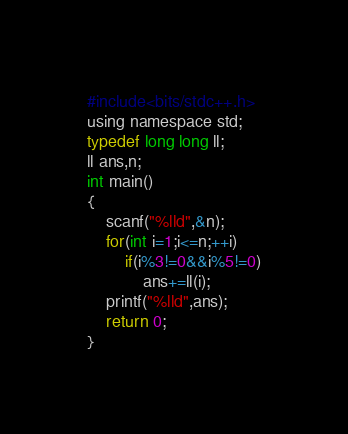Convert code to text. <code><loc_0><loc_0><loc_500><loc_500><_C_>#include<bits/stdc++.h>
using namespace std;
typedef long long ll;
ll ans,n;
int main()
{
	scanf("%lld",&n);
	for(int i=1;i<=n;++i)
		if(i%3!=0&&i%5!=0)
			ans+=ll(i);
	printf("%lld",ans);
	return 0; 
}</code> 